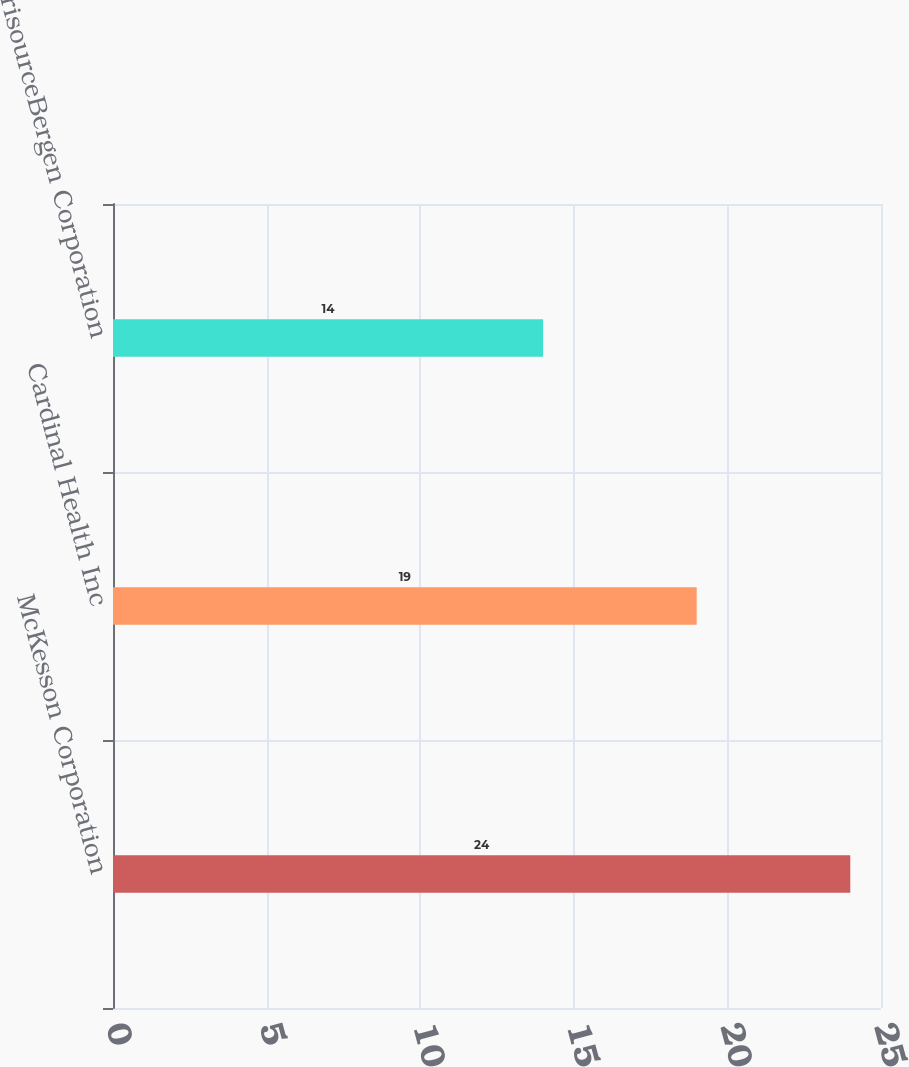<chart> <loc_0><loc_0><loc_500><loc_500><bar_chart><fcel>McKesson Corporation<fcel>Cardinal Health Inc<fcel>AmerisourceBergen Corporation<nl><fcel>24<fcel>19<fcel>14<nl></chart> 